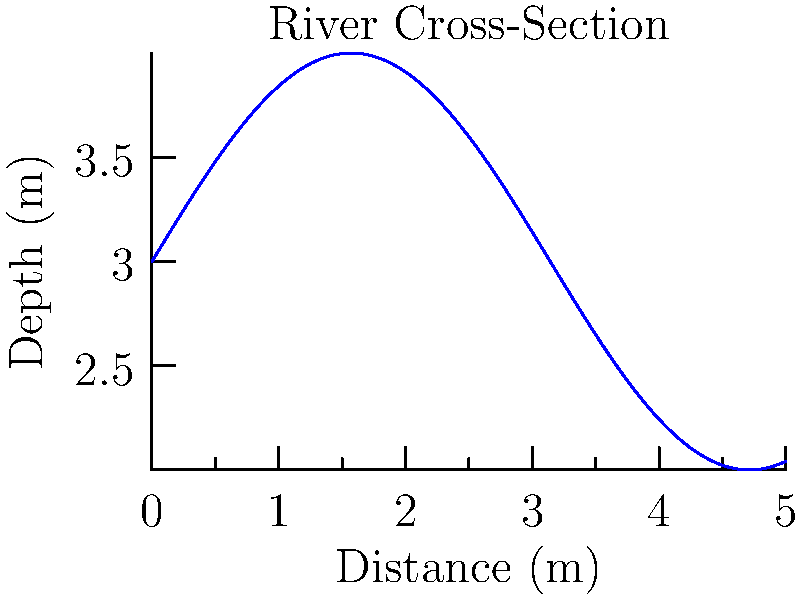Given the cross-sectional area graph of a river shown above, estimate the volume of water (in cubic meters) that flows through this section in 1 minute if the average flow velocity is 2 m/s. Assume the width of the river is constant at 5 meters. To solve this problem, we need to follow these steps:

1. Estimate the average depth of the river from the graph:
   The depth varies from about 3m to 4m. Let's estimate the average depth as 3.5m.

2. Calculate the cross-sectional area:
   Area = Width × Average Depth
   $A = 5m \times 3.5m = 17.5m^2$

3. Calculate the flow rate:
   Flow Rate = Cross-sectional Area × Velocity
   $Q = A \times v = 17.5m^2 \times 2m/s = 35m^3/s$

4. Calculate the volume of water flowing in 1 minute:
   Volume = Flow Rate × Time
   $V = Q \times t = 35m^3/s \times 60s = 2100m^3$

Therefore, the estimated volume of water flowing through this section in 1 minute is 2100 cubic meters.
Answer: 2100 $m^3$ 